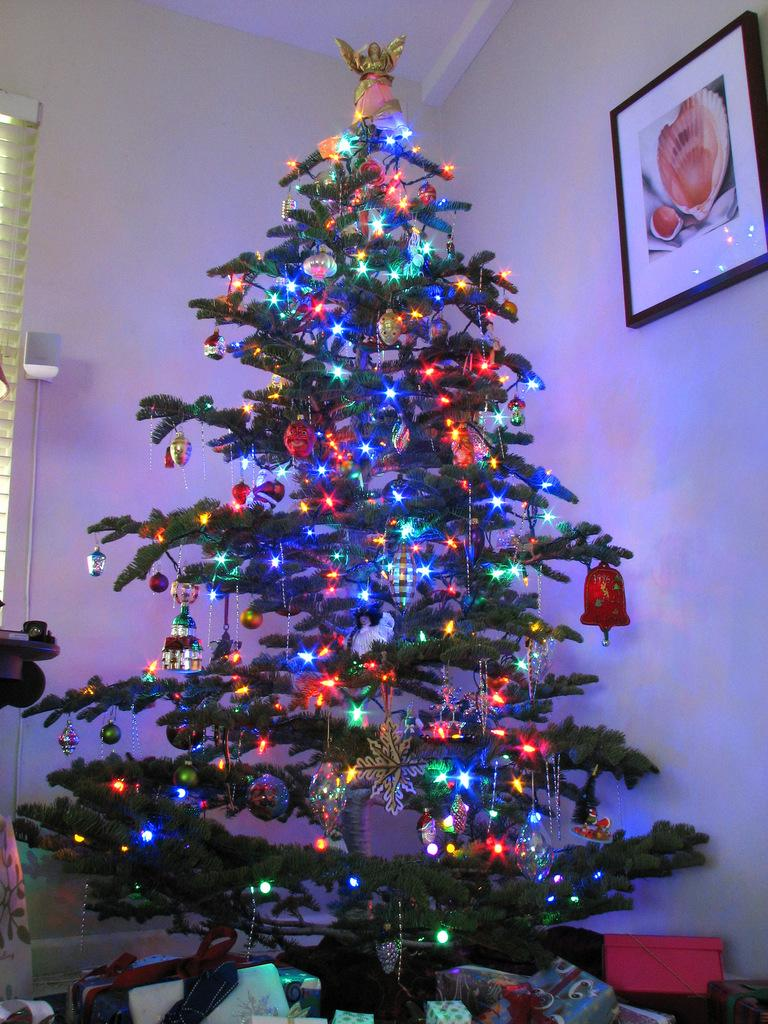What type of tree is in the image? There is a Christmas tree in the image. What decorations are on the Christmas tree? The Christmas tree has lights on it. What object is on the right side of the image? There is a photo frame on the right side of the image. What is on the left side of the image? There is a window blind on the left side of the image. What type of drug is the judge prescribing to the uncle in the image? There is no judge, uncle, or drug present in the image. 